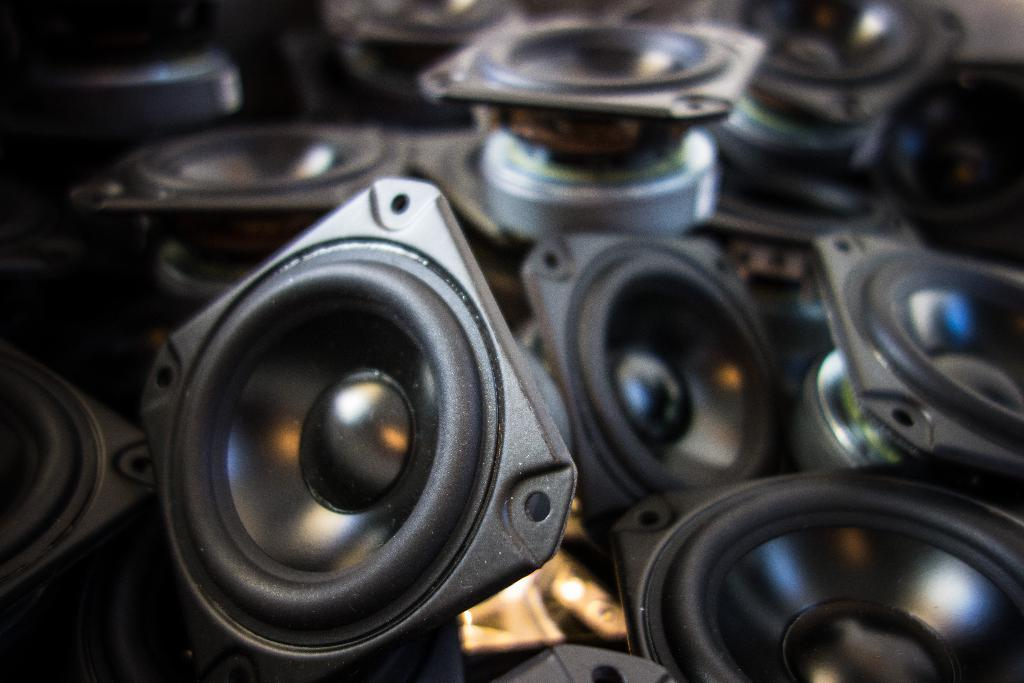What is located in the center of the image? There are objects in the center of the image. Can you describe the appearance of these objects? The objects resemble devices. Where is the cup placed in the image? There is no cup present in the image. Is there a doll visible in the image? There is no doll present in the image. 